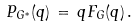Convert formula to latex. <formula><loc_0><loc_0><loc_500><loc_500>P _ { G ^ { * } } ( q ) \, = \, q F _ { G } ( q ) \, .</formula> 